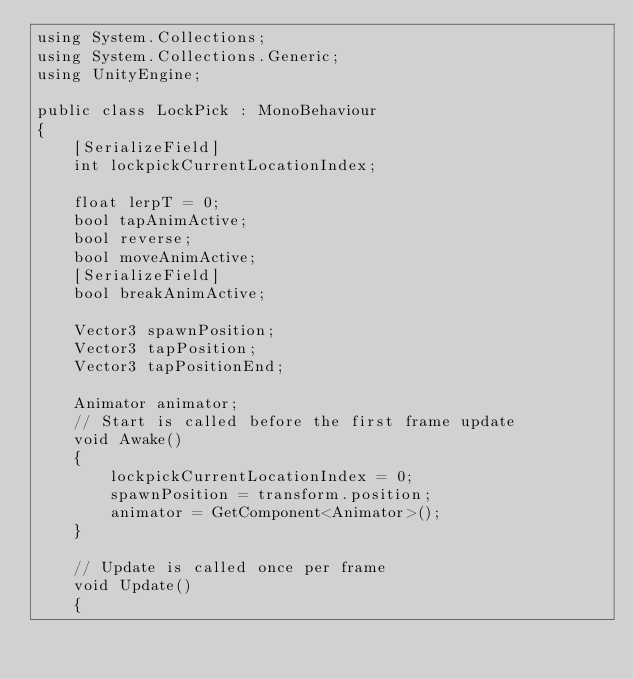Convert code to text. <code><loc_0><loc_0><loc_500><loc_500><_C#_>using System.Collections;
using System.Collections.Generic;
using UnityEngine;

public class LockPick : MonoBehaviour
{
    [SerializeField]
    int lockpickCurrentLocationIndex;

    float lerpT = 0;
    bool tapAnimActive;
    bool reverse;
    bool moveAnimActive;
    [SerializeField]
    bool breakAnimActive;

    Vector3 spawnPosition;
    Vector3 tapPosition;
    Vector3 tapPositionEnd;

    Animator animator;
    // Start is called before the first frame update
    void Awake()
    {
        lockpickCurrentLocationIndex = 0;
        spawnPosition = transform.position;
        animator = GetComponent<Animator>();
    }

    // Update is called once per frame
    void Update()
    {</code> 